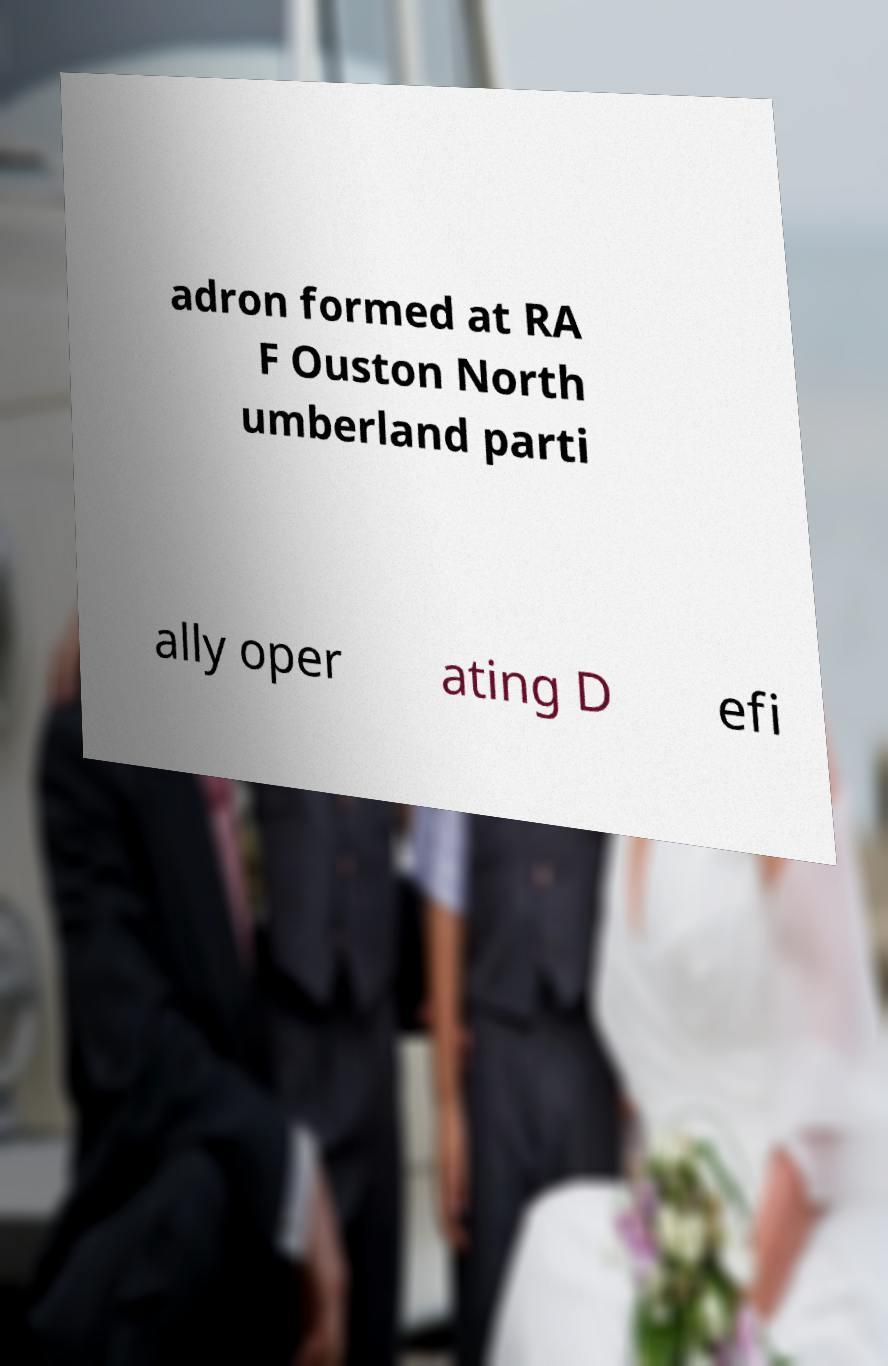Could you extract and type out the text from this image? adron formed at RA F Ouston North umberland parti ally oper ating D efi 